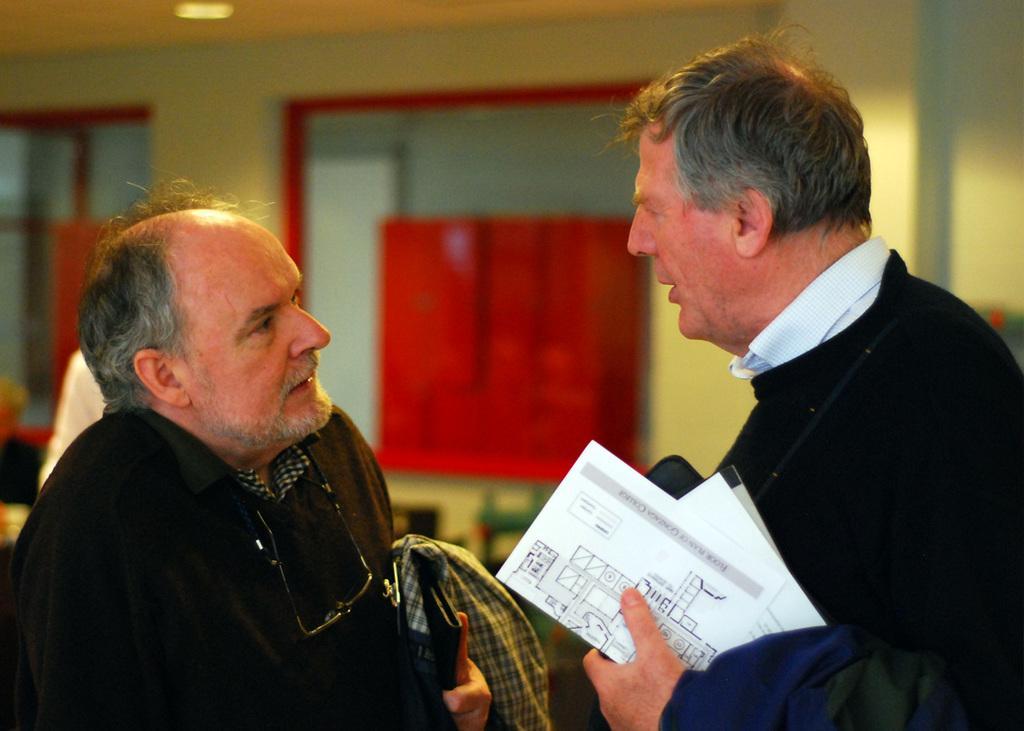Please provide a concise description of this image. In this image I can see two men wearing jackets and looking at each other. It seems like they are discussing something. The man who is on the right side is holding some papers in the hand. In the background, I can see the wall along with the windows. 